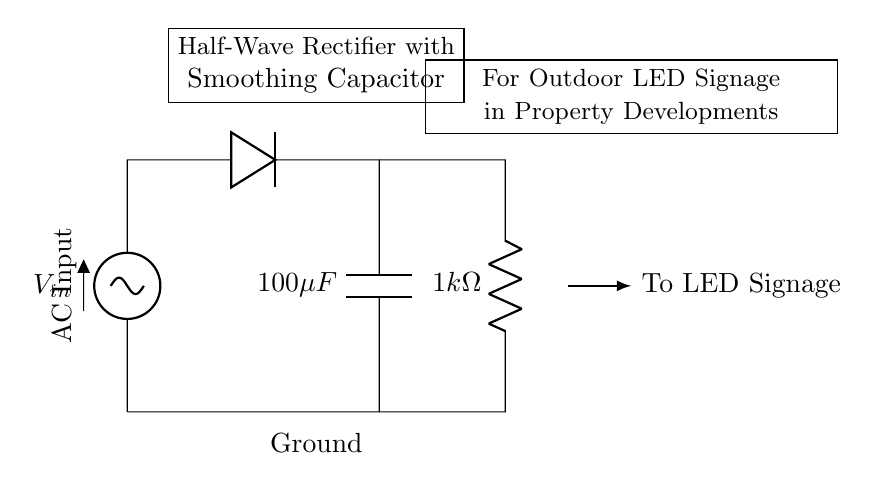What type of rectifier is shown in this circuit? The diagram labels the circuit as a "Half-Wave Rectifier," which means it uses one diode to only allow one half of the AC waveform to pass through.
Answer: Half-Wave Rectifier What is the value of the smoothing capacitor in this circuit? The circuit indicates that the smoothing capacitor, labeled as C, has a value of one hundred microfarads.
Answer: 100 microfarads What is the resistance value of the load resistor? The circuit diagram clearly shows the load resistor, labeled as R sub L, with a resistance value of one kilohm.
Answer: 1 kilohm What component is used to convert AC to DC in this circuit? The circuit diagram indicates the presence of a diode, which is responsible for converting alternating current (AC) into direct current (DC) by allowing current to flow in only one direction.
Answer: Diode How does the smoothing capacitor affect the output voltage? The smoothing capacitor charges when the output voltage from the rectifier increases and releases stored energy when it decreases, which helps to smooth out fluctuations in the output voltage, making it more constant for the LED signage.
Answer: It smooths the output voltage What is the purpose of the diode in this circuit? The diode's function in this circuit is to allow current to flow only during one half of the AC cycle, effectively blocking the negative half-cycle, thus transforming AC into pulsating DC for use in the LED signage.
Answer: To allow current in one direction 